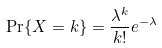Convert formula to latex. <formula><loc_0><loc_0><loc_500><loc_500>\Pr \{ X = k \} = \frac { \lambda ^ { k } } { k ! } e ^ { - \lambda }</formula> 